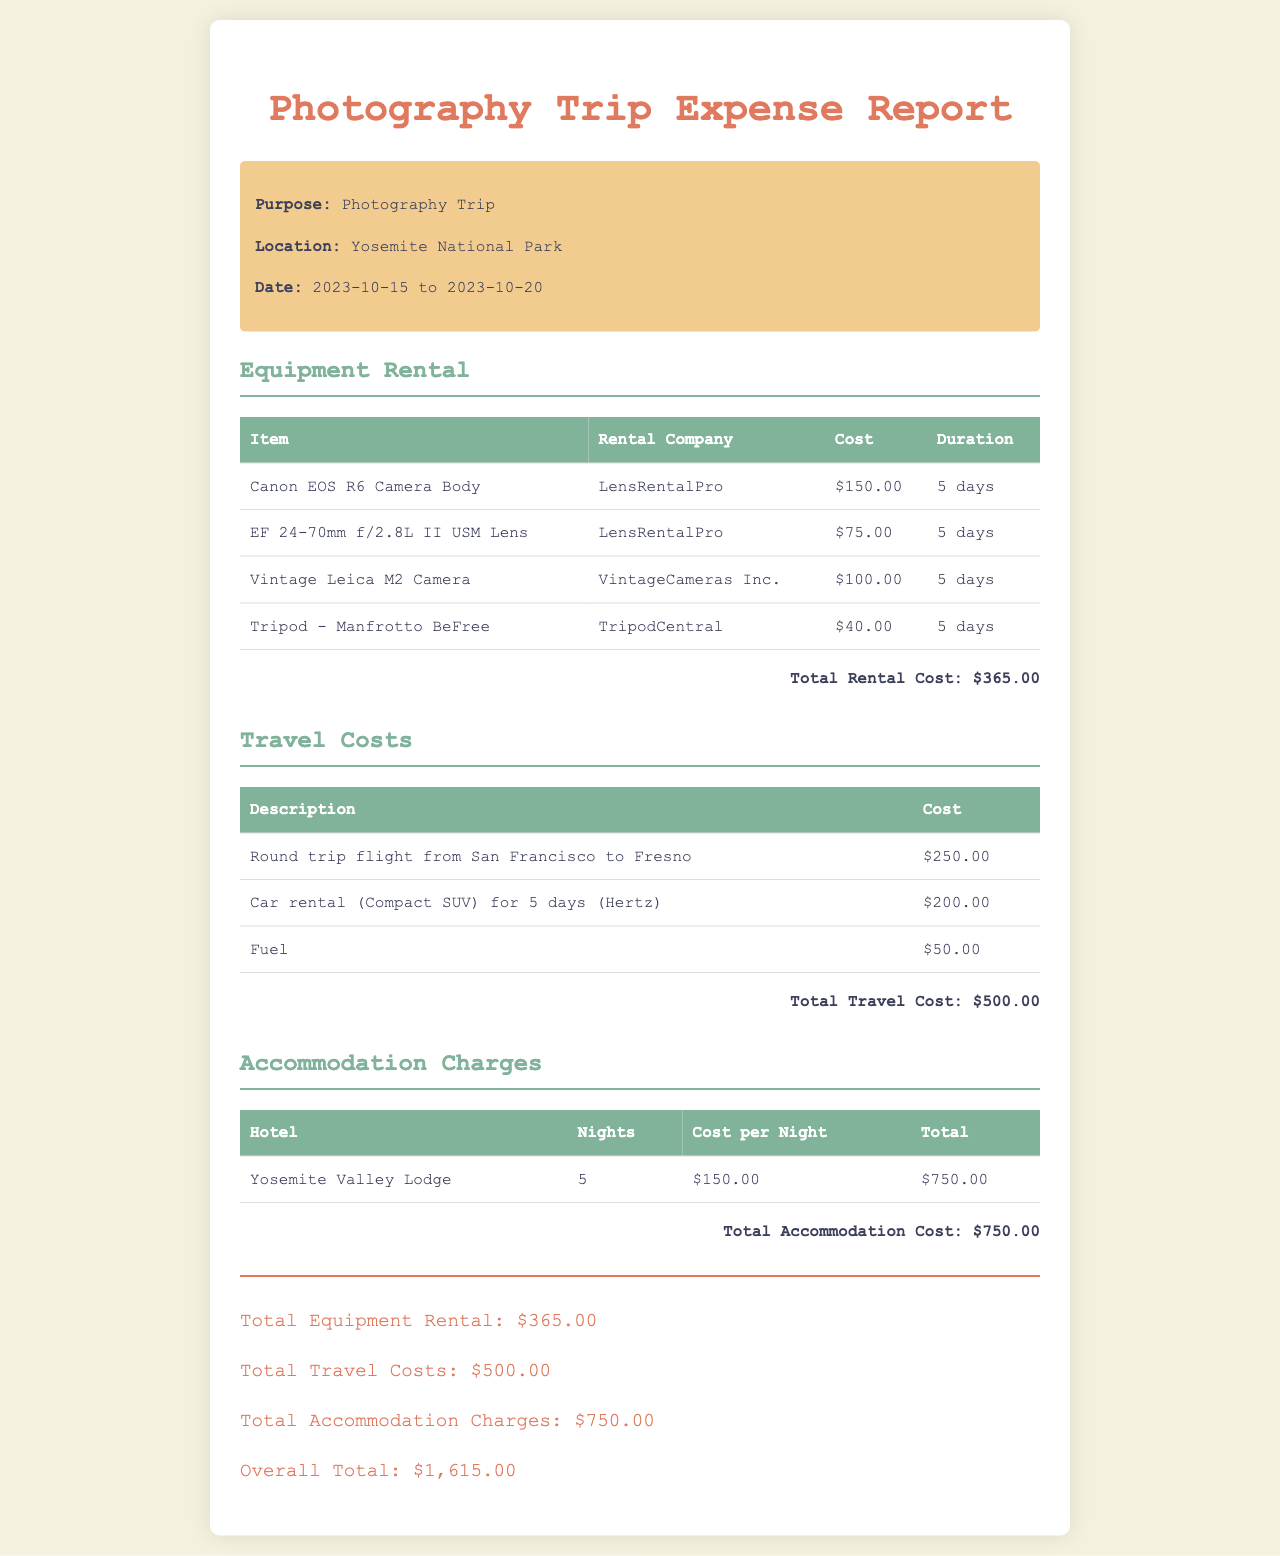What is the total accommodation cost? The total accommodation cost is detailed in the accommodation charges section as $750.00.
Answer: $750.00 What was the purpose of the trip? The purpose of the trip is stated at the beginning of the document.
Answer: Photography Trip Which rental company provided the Canon EOS R6 Camera Body? The rental company for the Canon EOS R6 Camera Body is mentioned in the equipment rental section.
Answer: LensRentalPro How many days was the tripod rented? The duration of the tripod rental is specified in the equipment rental table.
Answer: 5 days What is the overall total of the expenses? The overall total is calculated by summing all expense categories listed in the document.
Answer: $1,615.00 What is the cost of the round trip flight? The cost of the round trip flight is provided in the travel costs section.
Answer: $250.00 How many nights did the photographer stay at the Yosemite Valley Lodge? The number of nights is listed in the accommodation charges table for the lodge.
Answer: 5 What type of vehicle was rented for travel? The type of vehicle rented is detailed in the travel costs section.
Answer: Compact SUV 